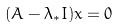<formula> <loc_0><loc_0><loc_500><loc_500>( A - \lambda _ { * } I ) x = 0</formula> 